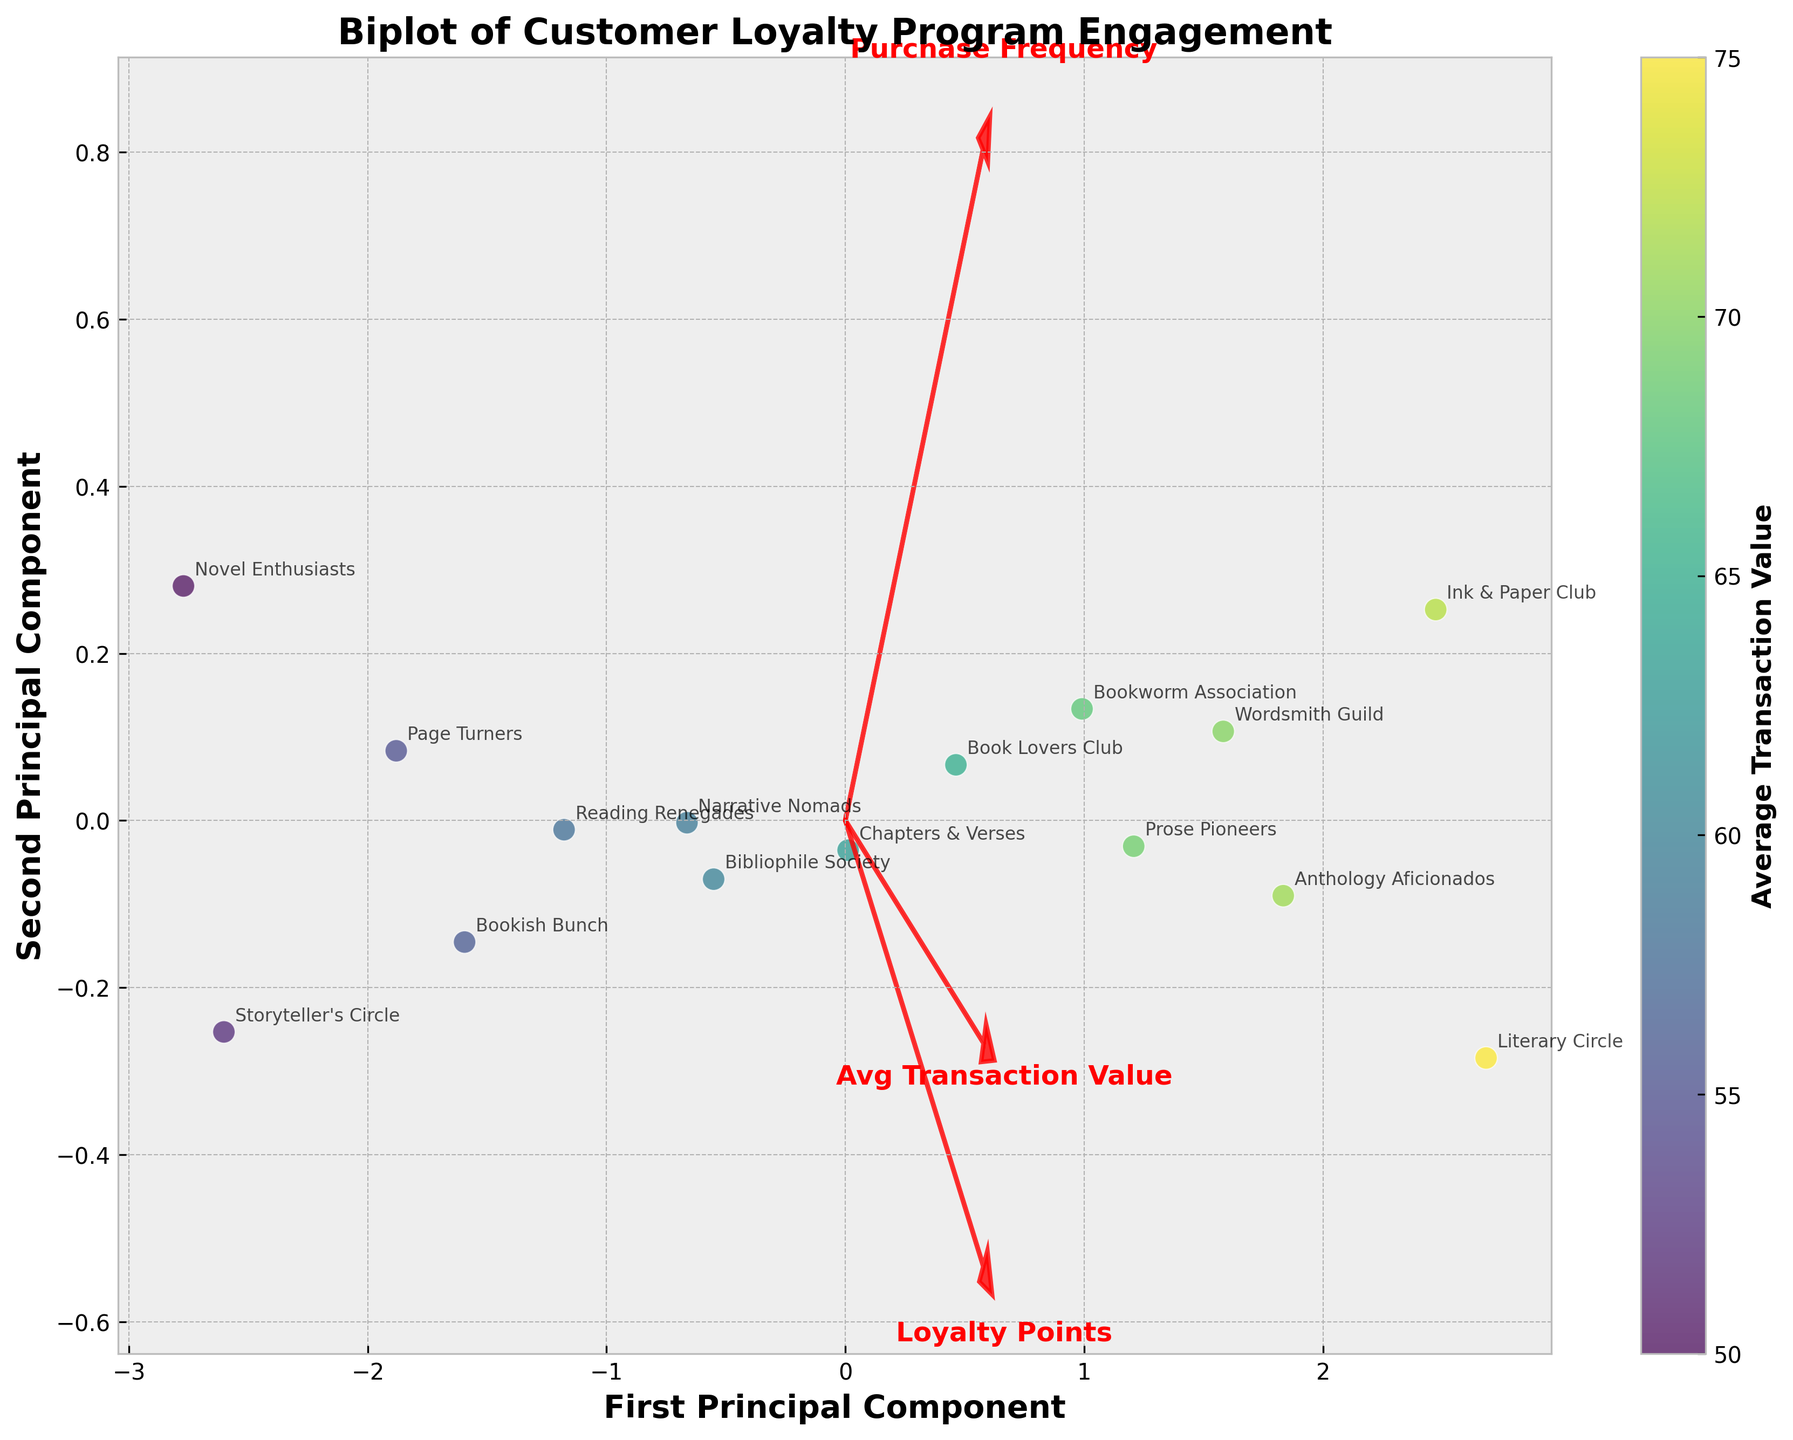what does the title of the plot indicate? The title of the plot is "Biplot of Customer Loyalty Program Engagement," indicating that this plot visualizes the engagement levels of different customer loyalty programs, considering multiple factors.
Answer: It indicates the engagement levels of customer loyalty programs how many principal components are represented in the plot? The x-axis and y-axis represent two principal components as indicated by the axis labels "First Principal Component" and "Second Principal Component".
Answer: Two principal components which customer loyalty program has the highest average transaction value? The color intensity of the data points represents the average transaction value. The "Ink & Paper Club" data point is the most intense, indicating the highest average transaction value.
Answer: Ink & Paper Club how are "Loyalty Points" and "Purchase Frequency" visually represented in the plot? "Loyalty Points" and "Purchase Frequency" are represented by red arrows pointing in different directions; "Loyalty Points" is labeled directly on the arrow pointing right, and "Purchase Frequency" is labeled with the arrow pointing slightly upwards to the right.
Answer: Red arrows labeled "Loyalty Points" and "Purchase Frequency." how is the color gradient used in this biplot? The color gradient (from lighter to darker) indicates the average transaction value, with lighter colors representing lower values and darker colors higher values. This can be confirmed by the colorbar labeled "Average Transaction Value."
Answer: Indicates average transaction value which customer loyalty program engages the most frequently? Observing the data points, the "Ink & Paper Club" has the highest value along the "Purchase Frequency" axis, represented by its location furthest along the direction of the red arrow labeled "Purchase Frequency."
Answer: Ink & Paper Club which two features seem to have positive correlations based on their arrow directions? The arrows for "Loyalty Points" and "Avg Transaction Value" point in generally similar directions (both to the right), indicating a tendency to increase together, suggesting a positive correlation.
Answer: Loyalty Points and Avg Transaction Value are there any customers that score high in loyalty points but low in average transaction value? "Literary Circle" has one of the highest values in "Loyalty Points" (far right) but not the darkest color, indicating a relatively lower average transaction value.
Answer: Literary Circle which customer loyalty program scores the lowest in purchase frequency and average transaction value? The "Storyteller's Circle" is positioned lowest in the direction of the "Purchase Frequency" arrow and is one of the lightest colors, indicating the lowest scores in both metrics.
Answer: Storyteller's Circle 